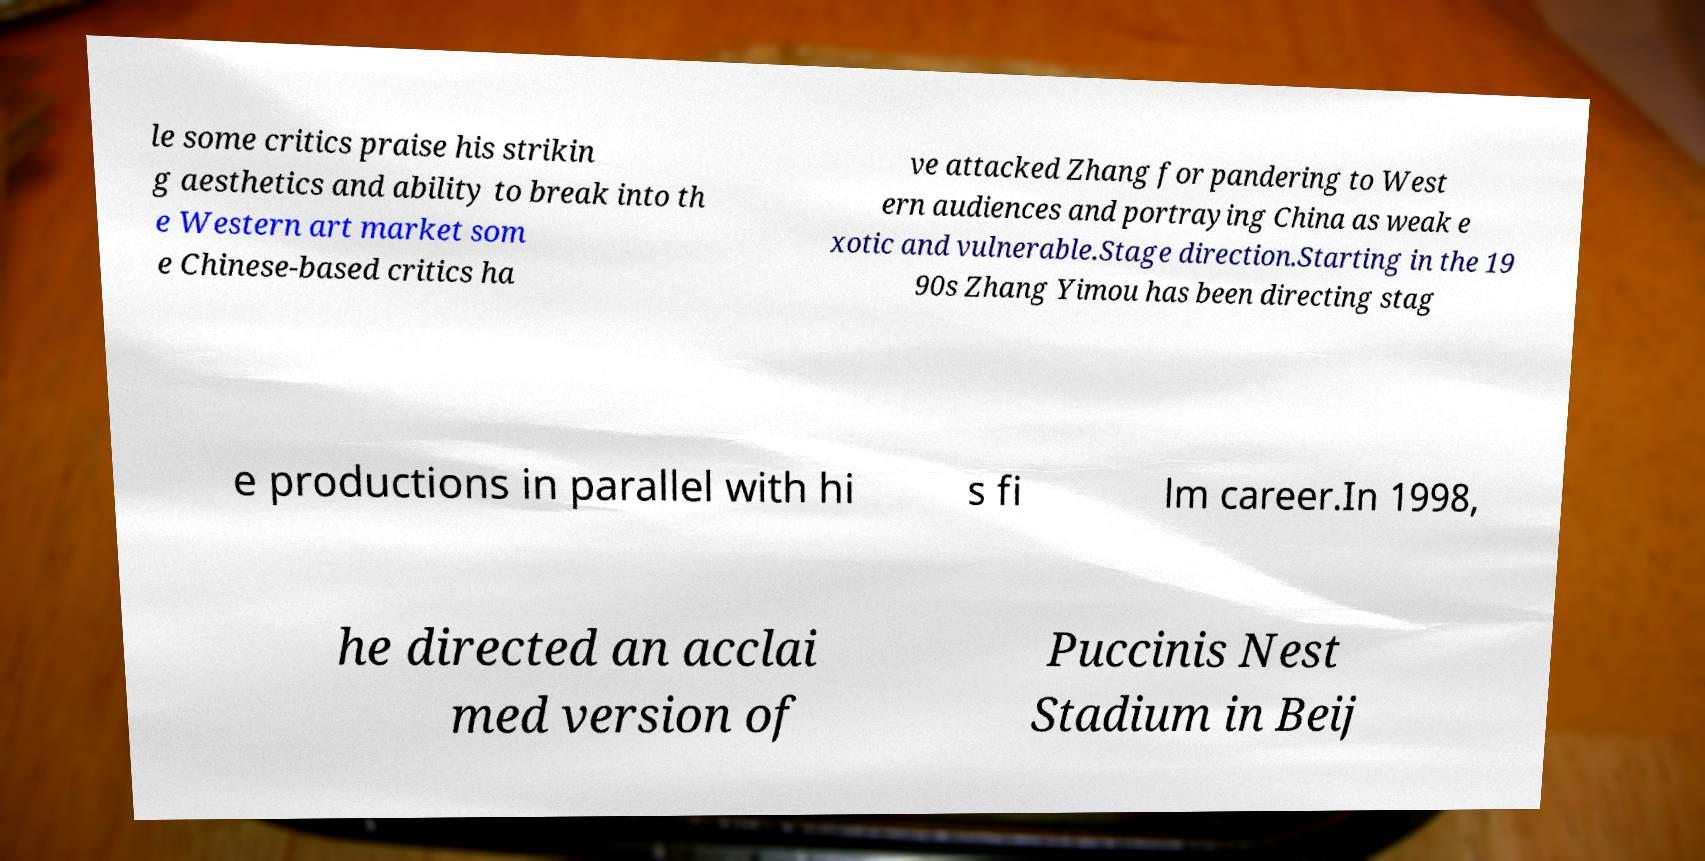Please read and relay the text visible in this image. What does it say? le some critics praise his strikin g aesthetics and ability to break into th e Western art market som e Chinese-based critics ha ve attacked Zhang for pandering to West ern audiences and portraying China as weak e xotic and vulnerable.Stage direction.Starting in the 19 90s Zhang Yimou has been directing stag e productions in parallel with hi s fi lm career.In 1998, he directed an acclai med version of Puccinis Nest Stadium in Beij 